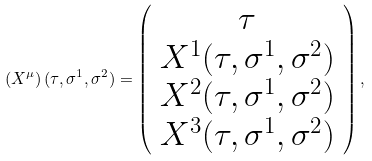Convert formula to latex. <formula><loc_0><loc_0><loc_500><loc_500>\left ( X ^ { \mu } \right ) ( \tau , \sigma ^ { 1 } , \sigma ^ { 2 } ) = \left ( \begin{array} { c } \tau \\ X ^ { 1 } ( \tau , \sigma ^ { 1 } , \sigma ^ { 2 } ) \\ X ^ { 2 } ( \tau , \sigma ^ { 1 } , \sigma ^ { 2 } ) \\ X ^ { 3 } ( \tau , \sigma ^ { 1 } , \sigma ^ { 2 } ) \end{array} \right ) ,</formula> 